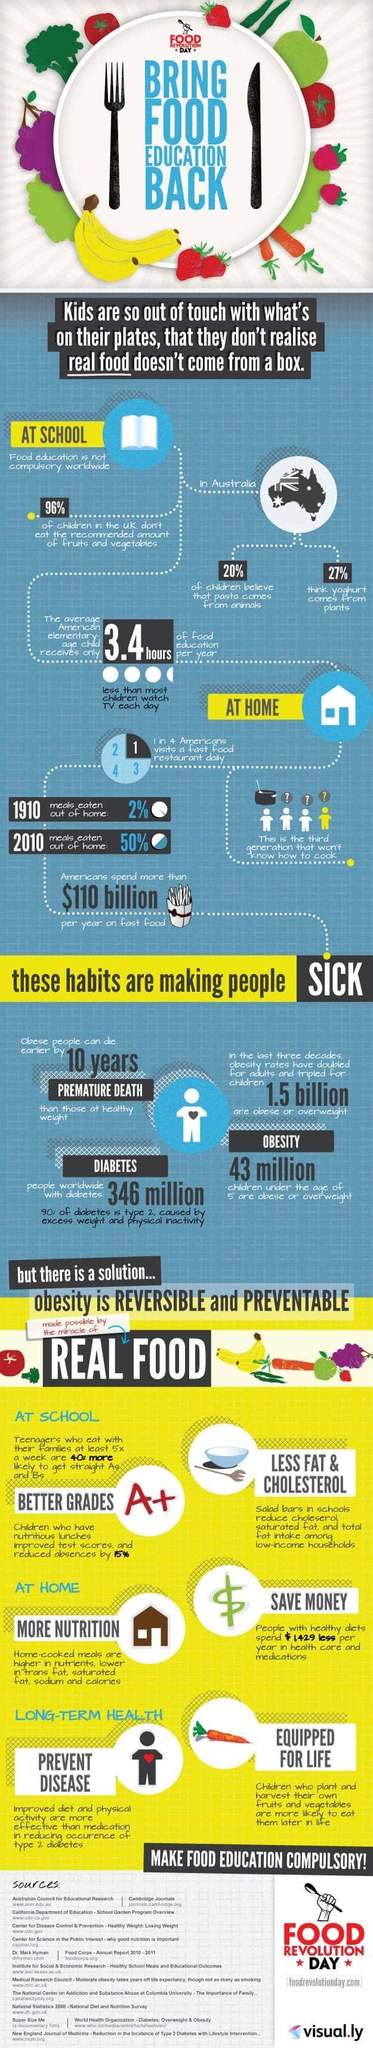What is less than most elementary age children's Tv time in America?
Answer the question with a short phrase. Food education What do 2 in 10 kids believe in Australia? pasta comes from animals What is the increase in percentage of meals eaten out of home from 1910 to 2010? 48% What percent of Americans visit a fast food restaurant daily? 25% 